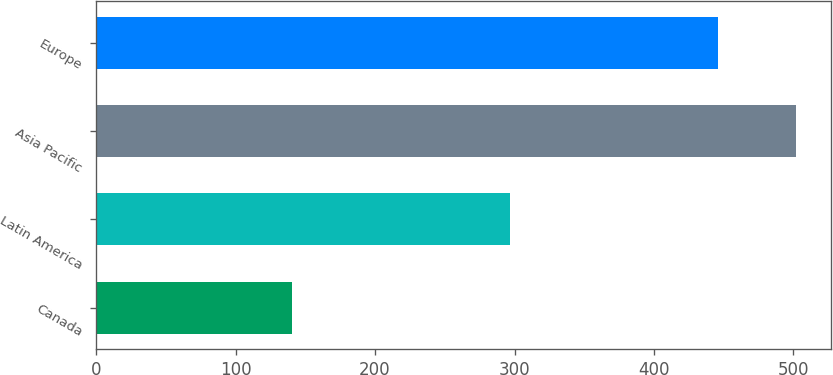<chart> <loc_0><loc_0><loc_500><loc_500><bar_chart><fcel>Canada<fcel>Latin America<fcel>Asia Pacific<fcel>Europe<nl><fcel>140.3<fcel>297.1<fcel>502.1<fcel>446.2<nl></chart> 